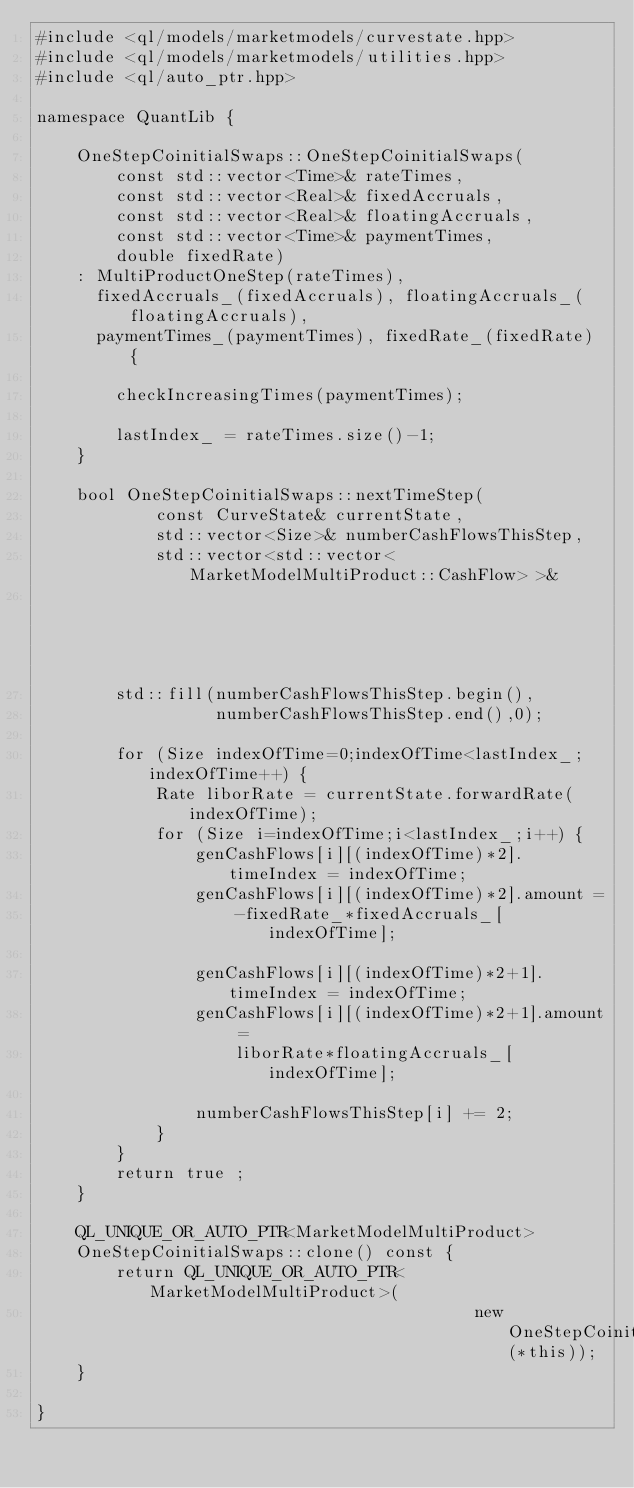<code> <loc_0><loc_0><loc_500><loc_500><_C++_>#include <ql/models/marketmodels/curvestate.hpp>
#include <ql/models/marketmodels/utilities.hpp>
#include <ql/auto_ptr.hpp>

namespace QuantLib {

    OneStepCoinitialSwaps::OneStepCoinitialSwaps(
        const std::vector<Time>& rateTimes,
        const std::vector<Real>& fixedAccruals,
        const std::vector<Real>& floatingAccruals,
        const std::vector<Time>& paymentTimes,
        double fixedRate)
    : MultiProductOneStep(rateTimes),
      fixedAccruals_(fixedAccruals), floatingAccruals_(floatingAccruals),
      paymentTimes_(paymentTimes), fixedRate_(fixedRate) {

        checkIncreasingTimes(paymentTimes);

        lastIndex_ = rateTimes.size()-1;
    }

    bool OneStepCoinitialSwaps::nextTimeStep(
            const CurveState& currentState,
            std::vector<Size>& numberCashFlowsThisStep,
            std::vector<std::vector<MarketModelMultiProduct::CashFlow> >&
                                                               genCashFlows) {
        std::fill(numberCashFlowsThisStep.begin(),
                  numberCashFlowsThisStep.end(),0);

        for (Size indexOfTime=0;indexOfTime<lastIndex_;indexOfTime++) {
            Rate liborRate = currentState.forwardRate(indexOfTime);
            for (Size i=indexOfTime;i<lastIndex_;i++) {
                genCashFlows[i][(indexOfTime)*2].timeIndex = indexOfTime;
                genCashFlows[i][(indexOfTime)*2].amount =
                    -fixedRate_*fixedAccruals_[indexOfTime];

                genCashFlows[i][(indexOfTime)*2+1].timeIndex = indexOfTime;
                genCashFlows[i][(indexOfTime)*2+1].amount =
                    liborRate*floatingAccruals_[indexOfTime];

                numberCashFlowsThisStep[i] += 2;
            }
        }
        return true ;
    }

    QL_UNIQUE_OR_AUTO_PTR<MarketModelMultiProduct>
    OneStepCoinitialSwaps::clone() const {
        return QL_UNIQUE_OR_AUTO_PTR<MarketModelMultiProduct>(
                                            new OneStepCoinitialSwaps(*this));
    }

}

</code> 